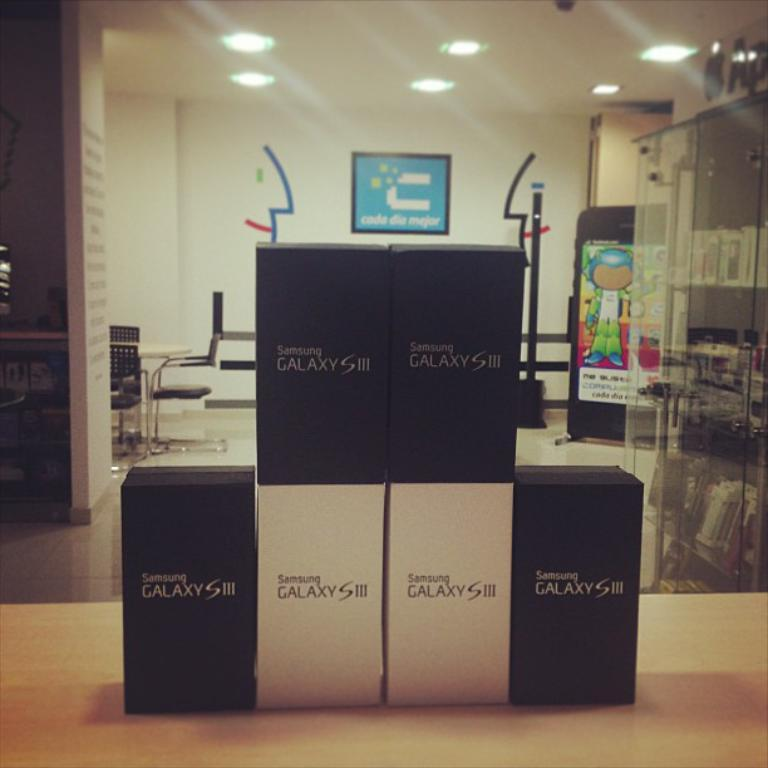<image>
Relay a brief, clear account of the picture shown. Black and white boxes for the Samsung Galaxy S III are stacked on a table. 